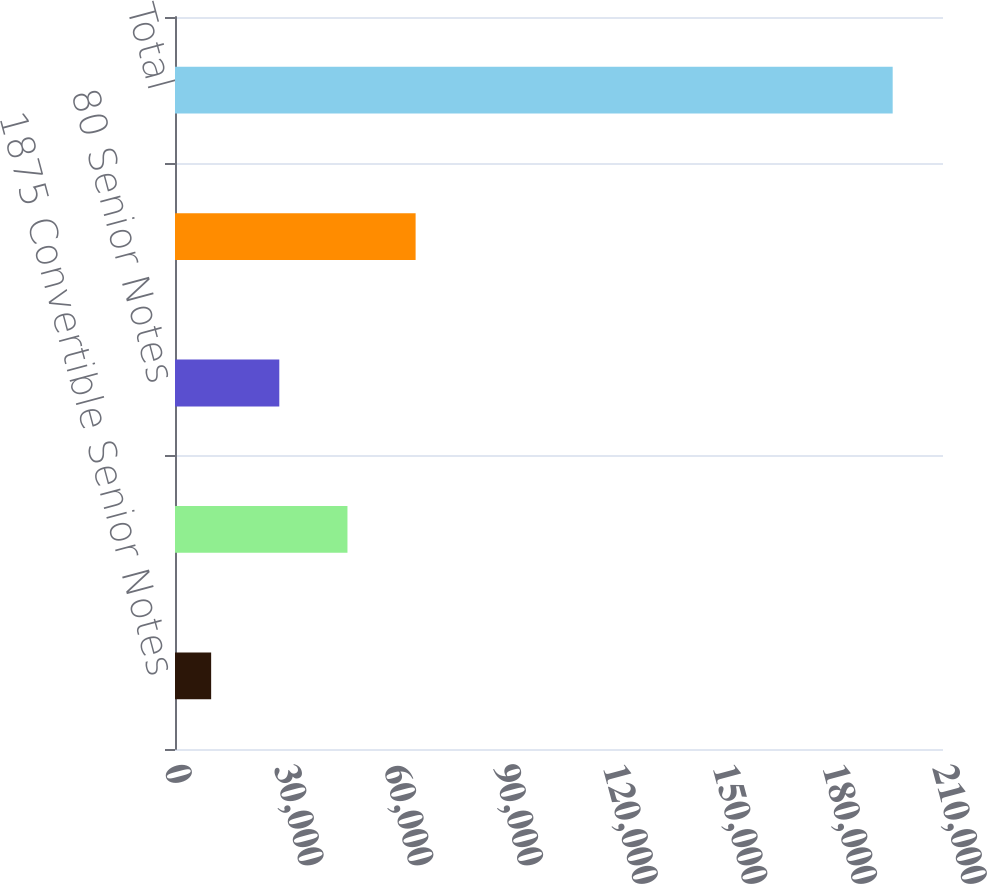Convert chart to OTSL. <chart><loc_0><loc_0><loc_500><loc_500><bar_chart><fcel>1875 Convertible Senior Notes<fcel>40 Convertible Senior Notes<fcel>80 Senior Notes<fcel>825 Senior Notes<fcel>Total<nl><fcel>9885<fcel>47156.2<fcel>28520.6<fcel>65791.8<fcel>196241<nl></chart> 